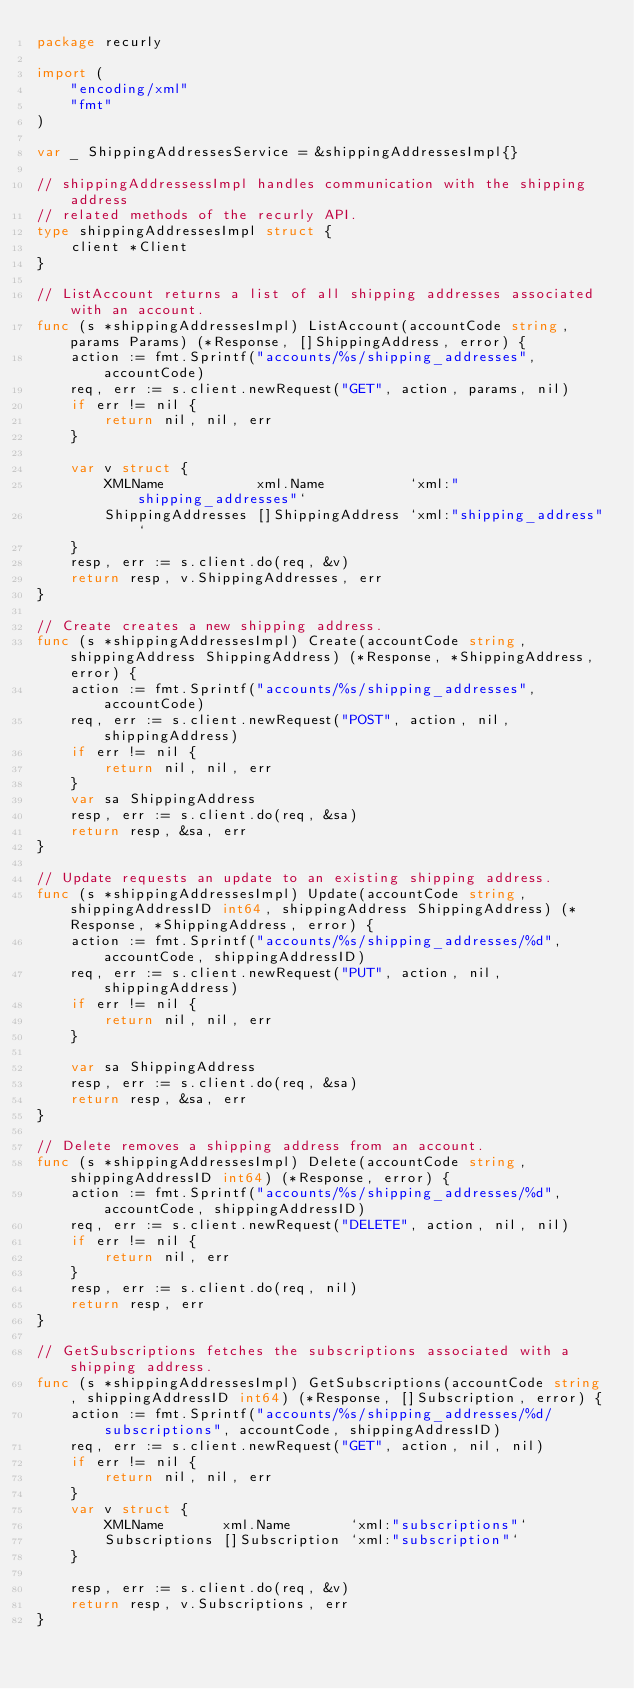<code> <loc_0><loc_0><loc_500><loc_500><_Go_>package recurly

import (
	"encoding/xml"
	"fmt"
)

var _ ShippingAddressesService = &shippingAddressesImpl{}

// shippingAddressessImpl handles communication with the shipping address
// related methods of the recurly API.
type shippingAddressesImpl struct {
	client *Client
}

// ListAccount returns a list of all shipping addresses associated with an account.
func (s *shippingAddressesImpl) ListAccount(accountCode string, params Params) (*Response, []ShippingAddress, error) {
	action := fmt.Sprintf("accounts/%s/shipping_addresses", accountCode)
	req, err := s.client.newRequest("GET", action, params, nil)
	if err != nil {
		return nil, nil, err
	}

	var v struct {
		XMLName           xml.Name          `xml:"shipping_addresses"`
		ShippingAddresses []ShippingAddress `xml:"shipping_address"`
	}
	resp, err := s.client.do(req, &v)
	return resp, v.ShippingAddresses, err
}

// Create creates a new shipping address.
func (s *shippingAddressesImpl) Create(accountCode string, shippingAddress ShippingAddress) (*Response, *ShippingAddress, error) {
	action := fmt.Sprintf("accounts/%s/shipping_addresses", accountCode)
	req, err := s.client.newRequest("POST", action, nil, shippingAddress)
	if err != nil {
		return nil, nil, err
	}
	var sa ShippingAddress
	resp, err := s.client.do(req, &sa)
	return resp, &sa, err
}

// Update requests an update to an existing shipping address.
func (s *shippingAddressesImpl) Update(accountCode string, shippingAddressID int64, shippingAddress ShippingAddress) (*Response, *ShippingAddress, error) {
	action := fmt.Sprintf("accounts/%s/shipping_addresses/%d", accountCode, shippingAddressID)
	req, err := s.client.newRequest("PUT", action, nil, shippingAddress)
	if err != nil {
		return nil, nil, err
	}

	var sa ShippingAddress
	resp, err := s.client.do(req, &sa)
	return resp, &sa, err
}

// Delete removes a shipping address from an account.
func (s *shippingAddressesImpl) Delete(accountCode string, shippingAddressID int64) (*Response, error) {
	action := fmt.Sprintf("accounts/%s/shipping_addresses/%d", accountCode, shippingAddressID)
	req, err := s.client.newRequest("DELETE", action, nil, nil)
	if err != nil {
		return nil, err
	}
	resp, err := s.client.do(req, nil)
	return resp, err
}

// GetSubscriptions fetches the subscriptions associated with a shipping address.
func (s *shippingAddressesImpl) GetSubscriptions(accountCode string, shippingAddressID int64) (*Response, []Subscription, error) {
	action := fmt.Sprintf("accounts/%s/shipping_addresses/%d/subscriptions", accountCode, shippingAddressID)
	req, err := s.client.newRequest("GET", action, nil, nil)
	if err != nil {
		return nil, nil, err
	}
	var v struct {
		XMLName       xml.Name       `xml:"subscriptions"`
		Subscriptions []Subscription `xml:"subscription"`
	}

	resp, err := s.client.do(req, &v)
	return resp, v.Subscriptions, err
}
</code> 